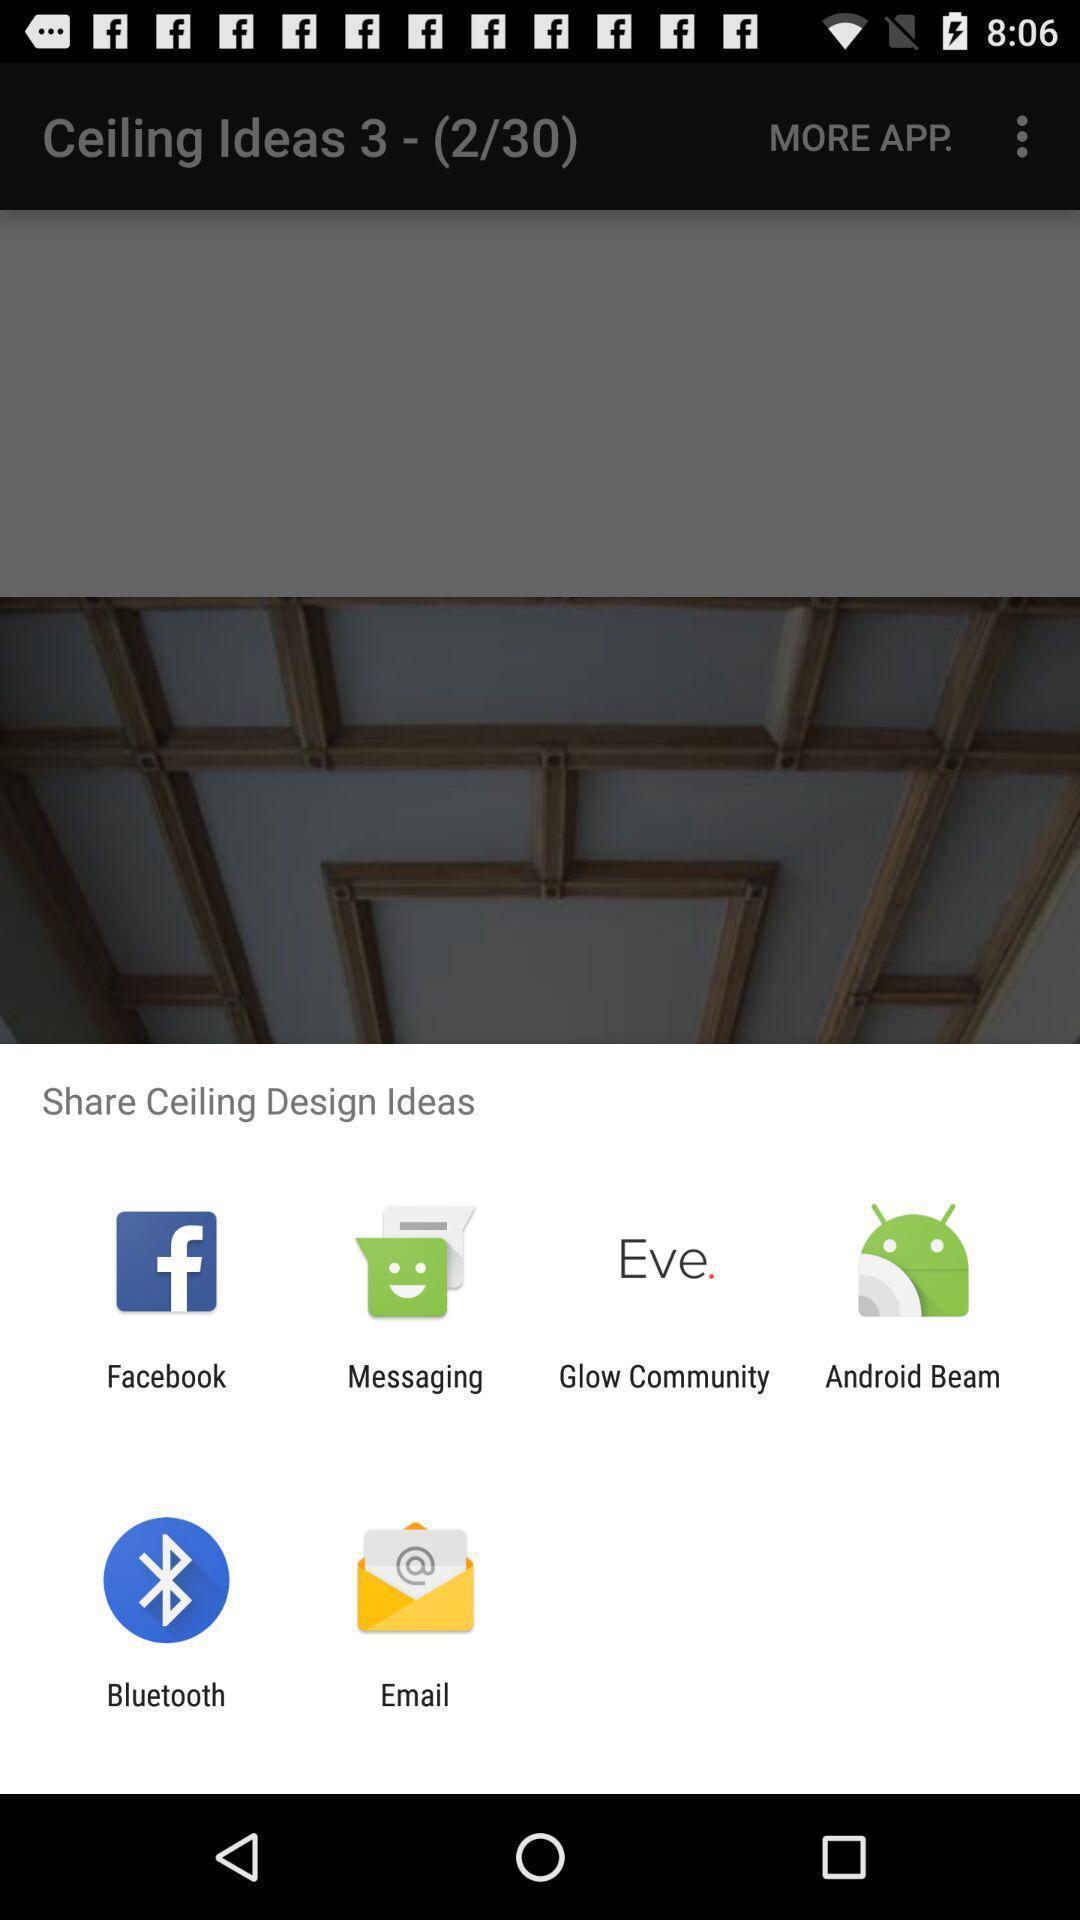What details can you identify in this image? Pop-up widget showing multiple data transferring apps. 